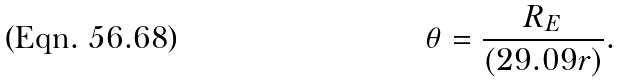<formula> <loc_0><loc_0><loc_500><loc_500>\theta = \frac { R _ { E } } { ( 2 9 . 0 9 r ) } .</formula> 